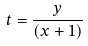<formula> <loc_0><loc_0><loc_500><loc_500>t = \frac { y } { ( x + 1 ) }</formula> 